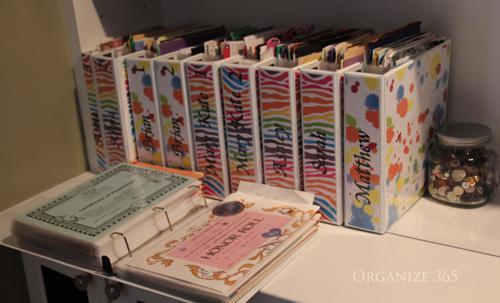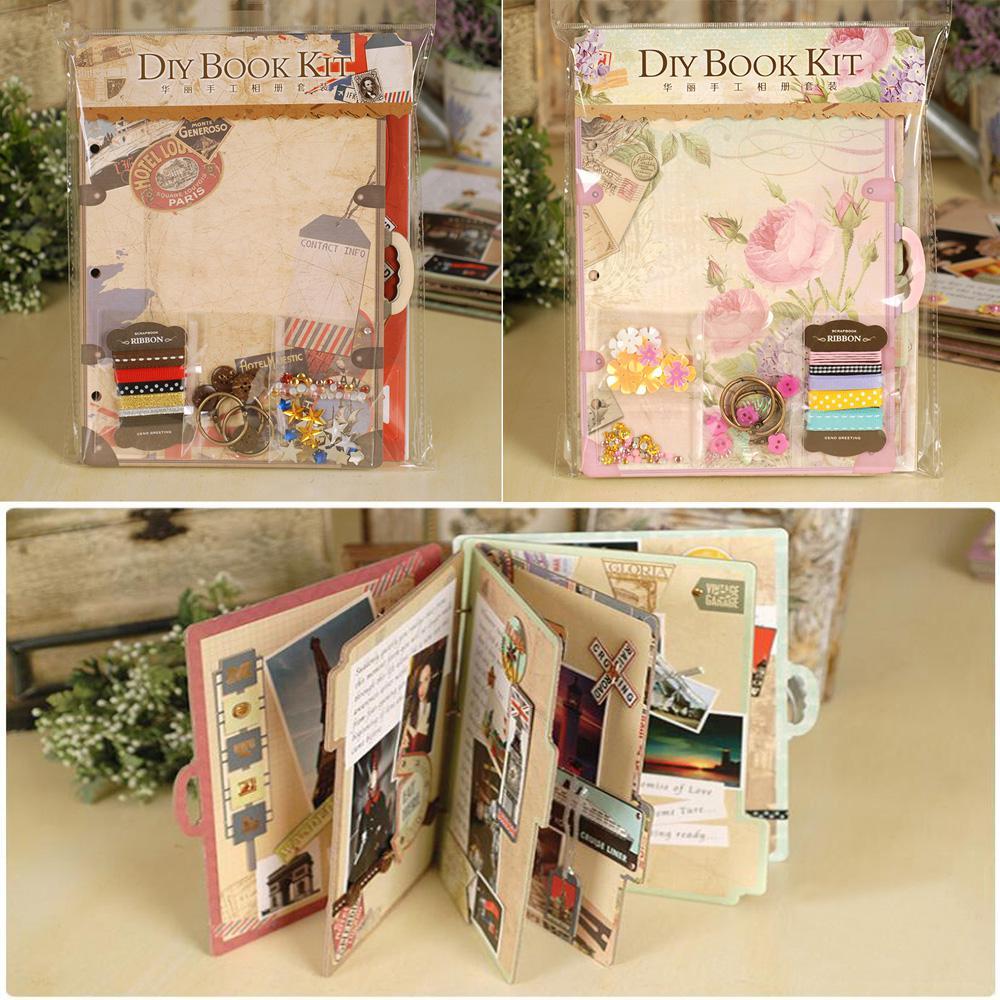The first image is the image on the left, the second image is the image on the right. Given the left and right images, does the statement "There are five colorful notebooks in one of the images." hold true? Answer yes or no. No. 